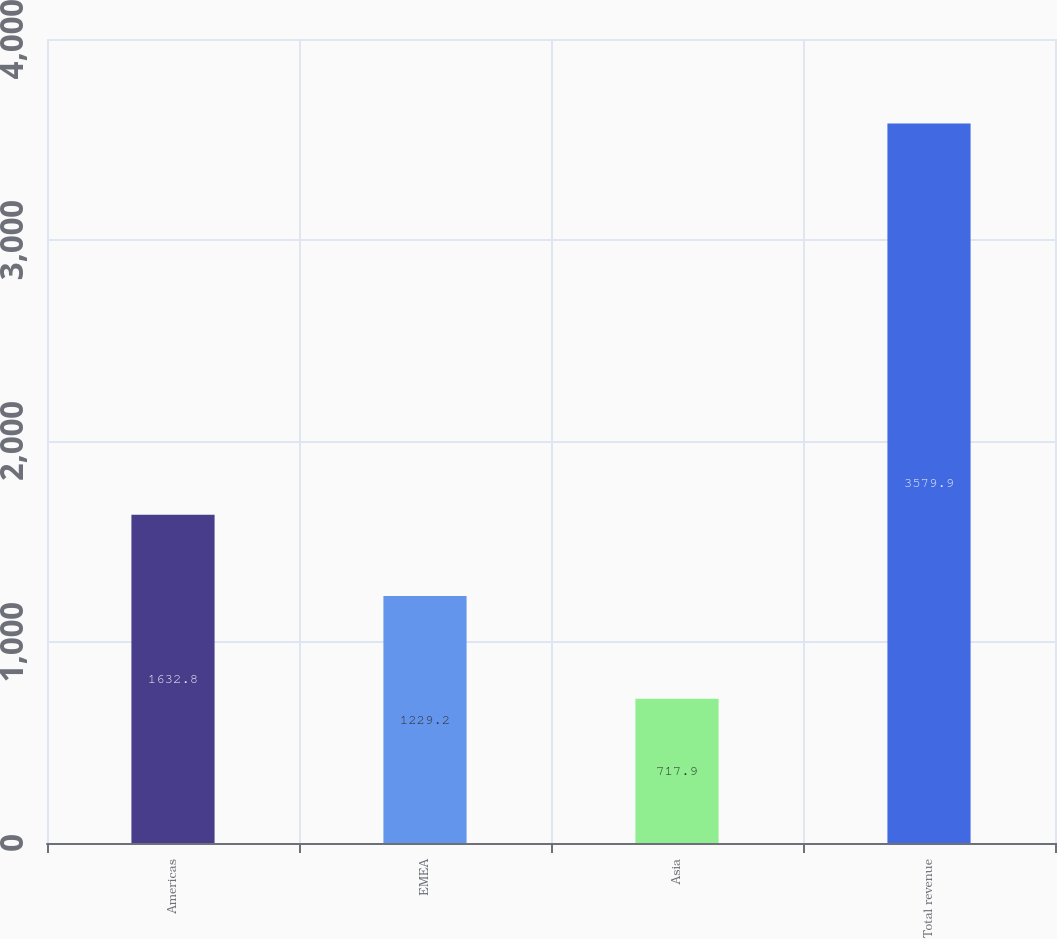Convert chart. <chart><loc_0><loc_0><loc_500><loc_500><bar_chart><fcel>Americas<fcel>EMEA<fcel>Asia<fcel>Total revenue<nl><fcel>1632.8<fcel>1229.2<fcel>717.9<fcel>3579.9<nl></chart> 